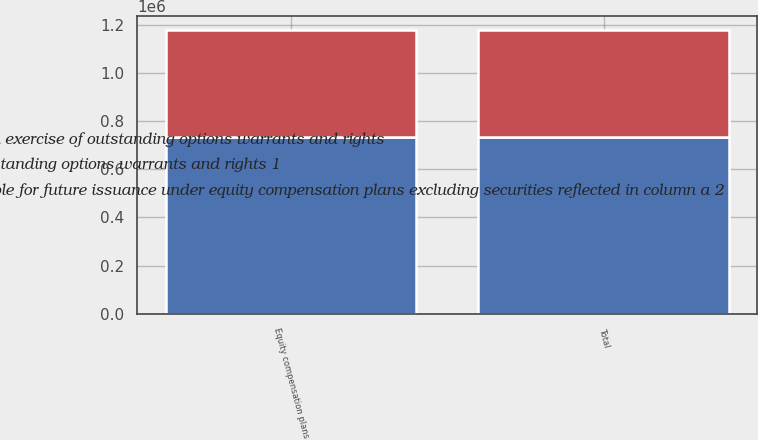Convert chart to OTSL. <chart><loc_0><loc_0><loc_500><loc_500><stacked_bar_chart><ecel><fcel>Equity compensation plans<fcel>Total<nl><fcel>c Number of securities remaining available for future issuance under equity compensation plans excluding securities reflected in column a 2<fcel>442880<fcel>442880<nl><fcel>b Weightedaverage exercise price of outstanding options warrants and rights 1<fcel>51.85<fcel>51.85<nl><fcel>a Number of securities to be issued upon exercise of outstanding options warrants and rights<fcel>735297<fcel>735297<nl></chart> 